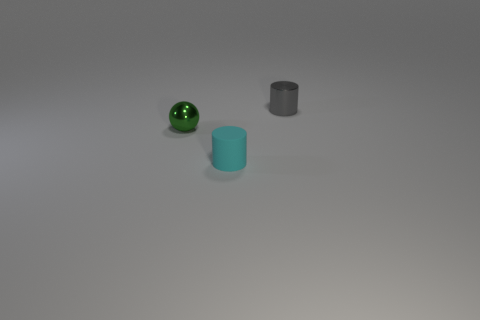Add 3 tiny cyan matte things. How many objects exist? 6 Subtract all balls. How many objects are left? 2 Subtract 1 green balls. How many objects are left? 2 Subtract all cyan objects. Subtract all green metallic spheres. How many objects are left? 1 Add 1 rubber things. How many rubber things are left? 2 Add 3 small green things. How many small green things exist? 4 